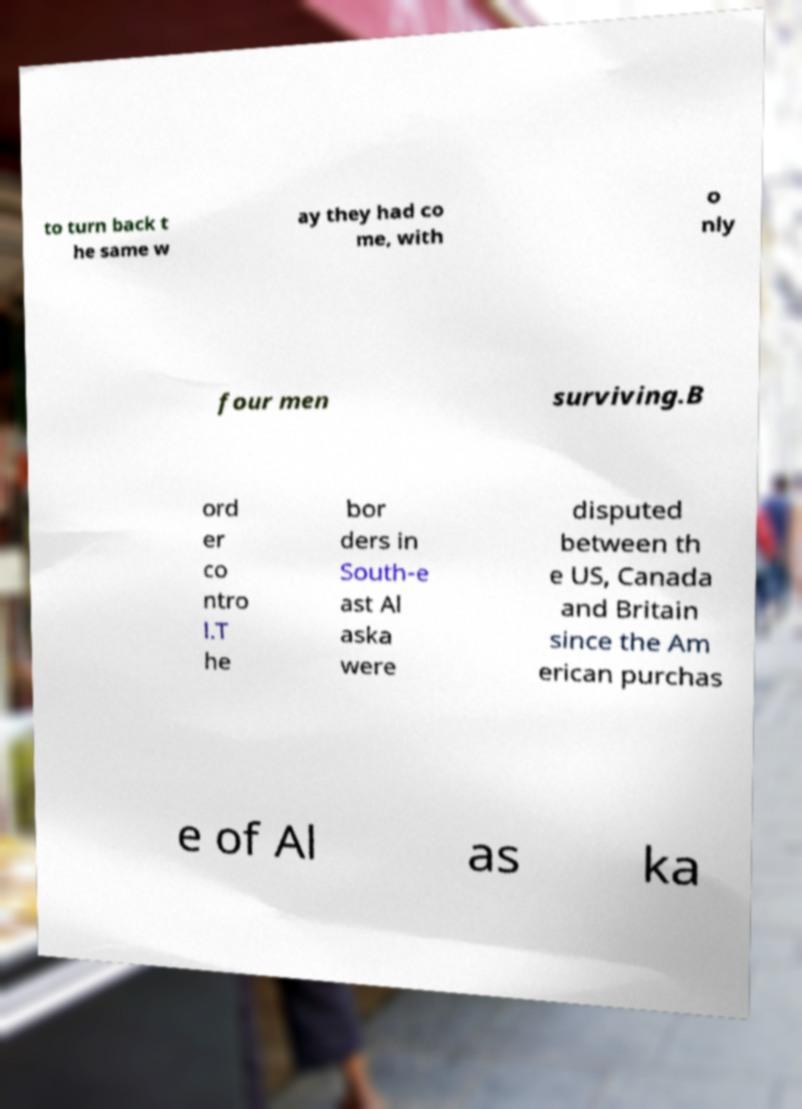Could you extract and type out the text from this image? to turn back t he same w ay they had co me, with o nly four men surviving.B ord er co ntro l.T he bor ders in South-e ast Al aska were disputed between th e US, Canada and Britain since the Am erican purchas e of Al as ka 